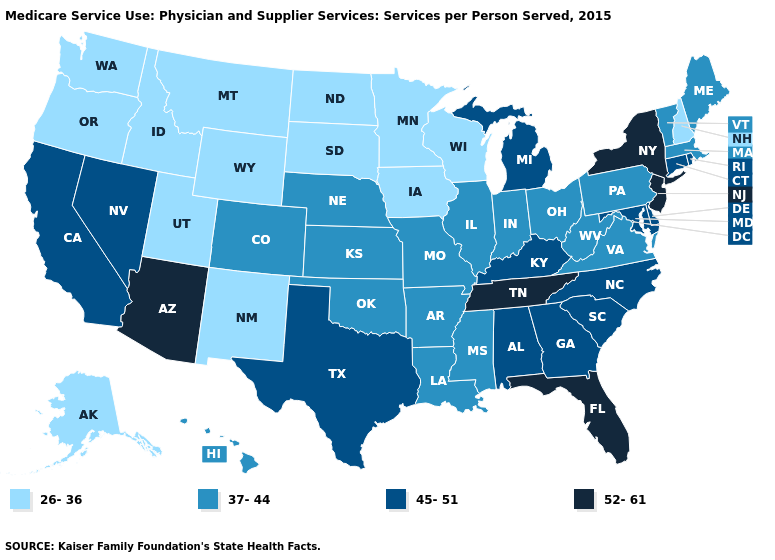Among the states that border Connecticut , does New York have the lowest value?
Give a very brief answer. No. Does the first symbol in the legend represent the smallest category?
Write a very short answer. Yes. Name the states that have a value in the range 45-51?
Short answer required. Alabama, California, Connecticut, Delaware, Georgia, Kentucky, Maryland, Michigan, Nevada, North Carolina, Rhode Island, South Carolina, Texas. Which states have the lowest value in the West?
Short answer required. Alaska, Idaho, Montana, New Mexico, Oregon, Utah, Washington, Wyoming. Does the map have missing data?
Keep it brief. No. What is the highest value in the MidWest ?
Keep it brief. 45-51. What is the value of Wyoming?
Give a very brief answer. 26-36. Does Colorado have the lowest value in the West?
Give a very brief answer. No. How many symbols are there in the legend?
Keep it brief. 4. Among the states that border West Virginia , which have the lowest value?
Write a very short answer. Ohio, Pennsylvania, Virginia. What is the value of Michigan?
Write a very short answer. 45-51. Name the states that have a value in the range 45-51?
Short answer required. Alabama, California, Connecticut, Delaware, Georgia, Kentucky, Maryland, Michigan, Nevada, North Carolina, Rhode Island, South Carolina, Texas. Name the states that have a value in the range 45-51?
Keep it brief. Alabama, California, Connecticut, Delaware, Georgia, Kentucky, Maryland, Michigan, Nevada, North Carolina, Rhode Island, South Carolina, Texas. 